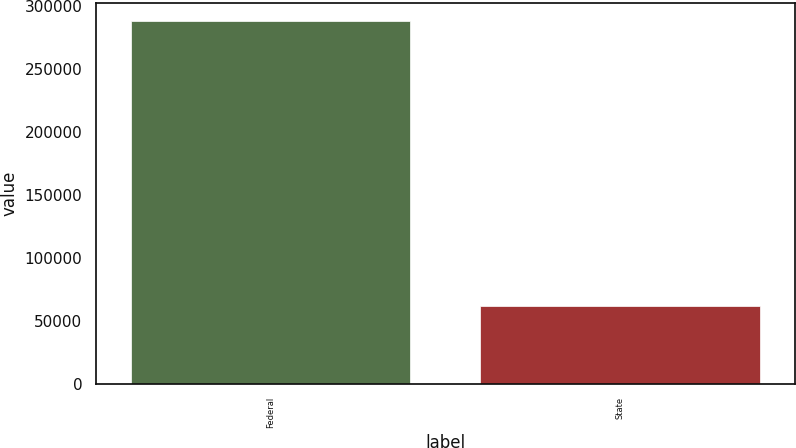<chart> <loc_0><loc_0><loc_500><loc_500><bar_chart><fcel>Federal<fcel>State<nl><fcel>288069<fcel>61503<nl></chart> 